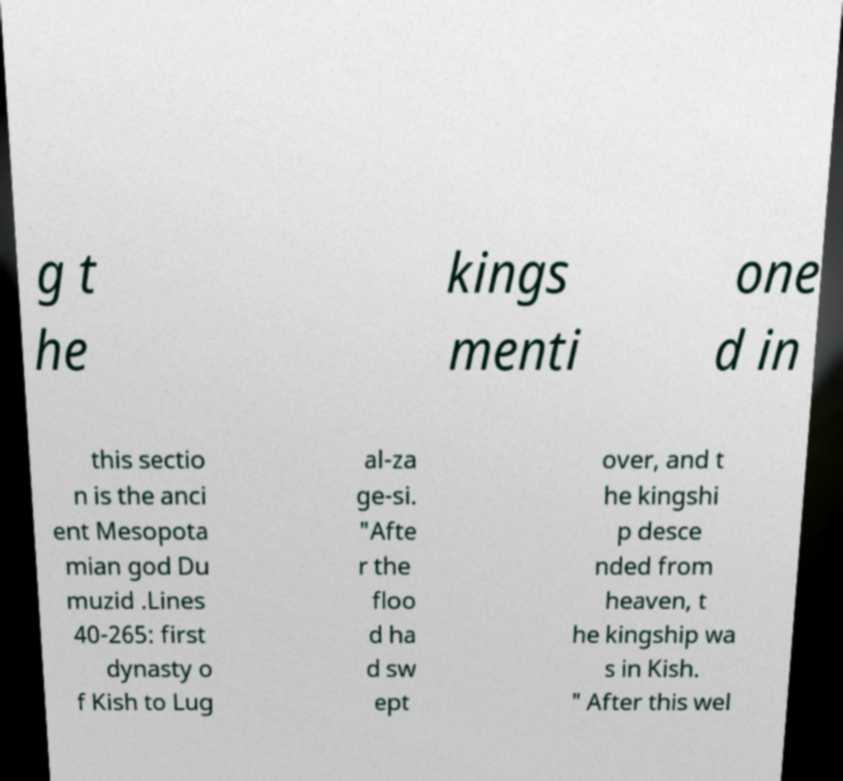There's text embedded in this image that I need extracted. Can you transcribe it verbatim? g t he kings menti one d in this sectio n is the anci ent Mesopota mian god Du muzid .Lines 40-265: first dynasty o f Kish to Lug al-za ge-si. "Afte r the floo d ha d sw ept over, and t he kingshi p desce nded from heaven, t he kingship wa s in Kish. " After this wel 